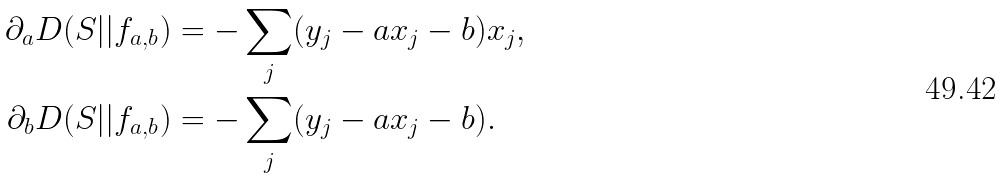Convert formula to latex. <formula><loc_0><loc_0><loc_500><loc_500>\partial _ { a } D ( S | | f _ { a , b } ) & = - \sum _ { j } ( y _ { j } - a x _ { j } - b ) x _ { j } , \\ \partial _ { b } D ( S | | f _ { a , b } ) & = - \sum _ { j } ( y _ { j } - a x _ { j } - b ) .</formula> 